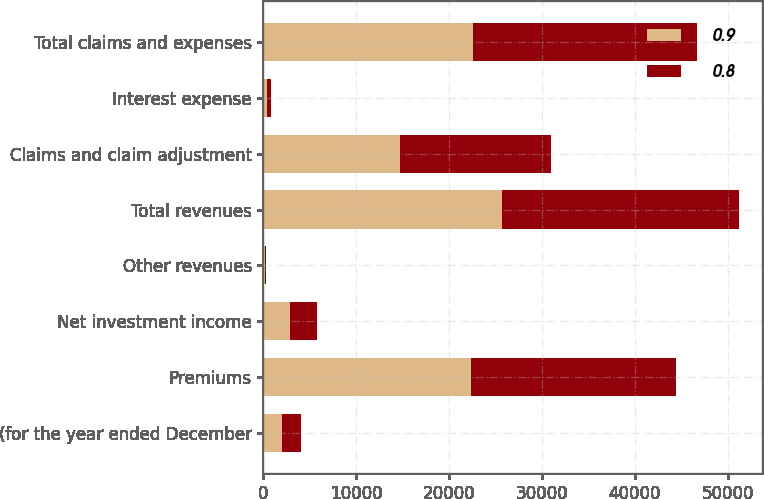Convert chart to OTSL. <chart><loc_0><loc_0><loc_500><loc_500><stacked_bar_chart><ecel><fcel>(for the year ended December<fcel>Premiums<fcel>Net investment income<fcel>Other revenues<fcel>Total revenues<fcel>Claims and claim adjustment<fcel>Interest expense<fcel>Total claims and expenses<nl><fcel>0.9<fcel>2012<fcel>22357<fcel>2889<fcel>120<fcel>25740<fcel>14676<fcel>378<fcel>22574<nl><fcel>0.8<fcel>2011<fcel>22090<fcel>2879<fcel>126<fcel>25446<fcel>16276<fcel>386<fcel>24094<nl></chart> 